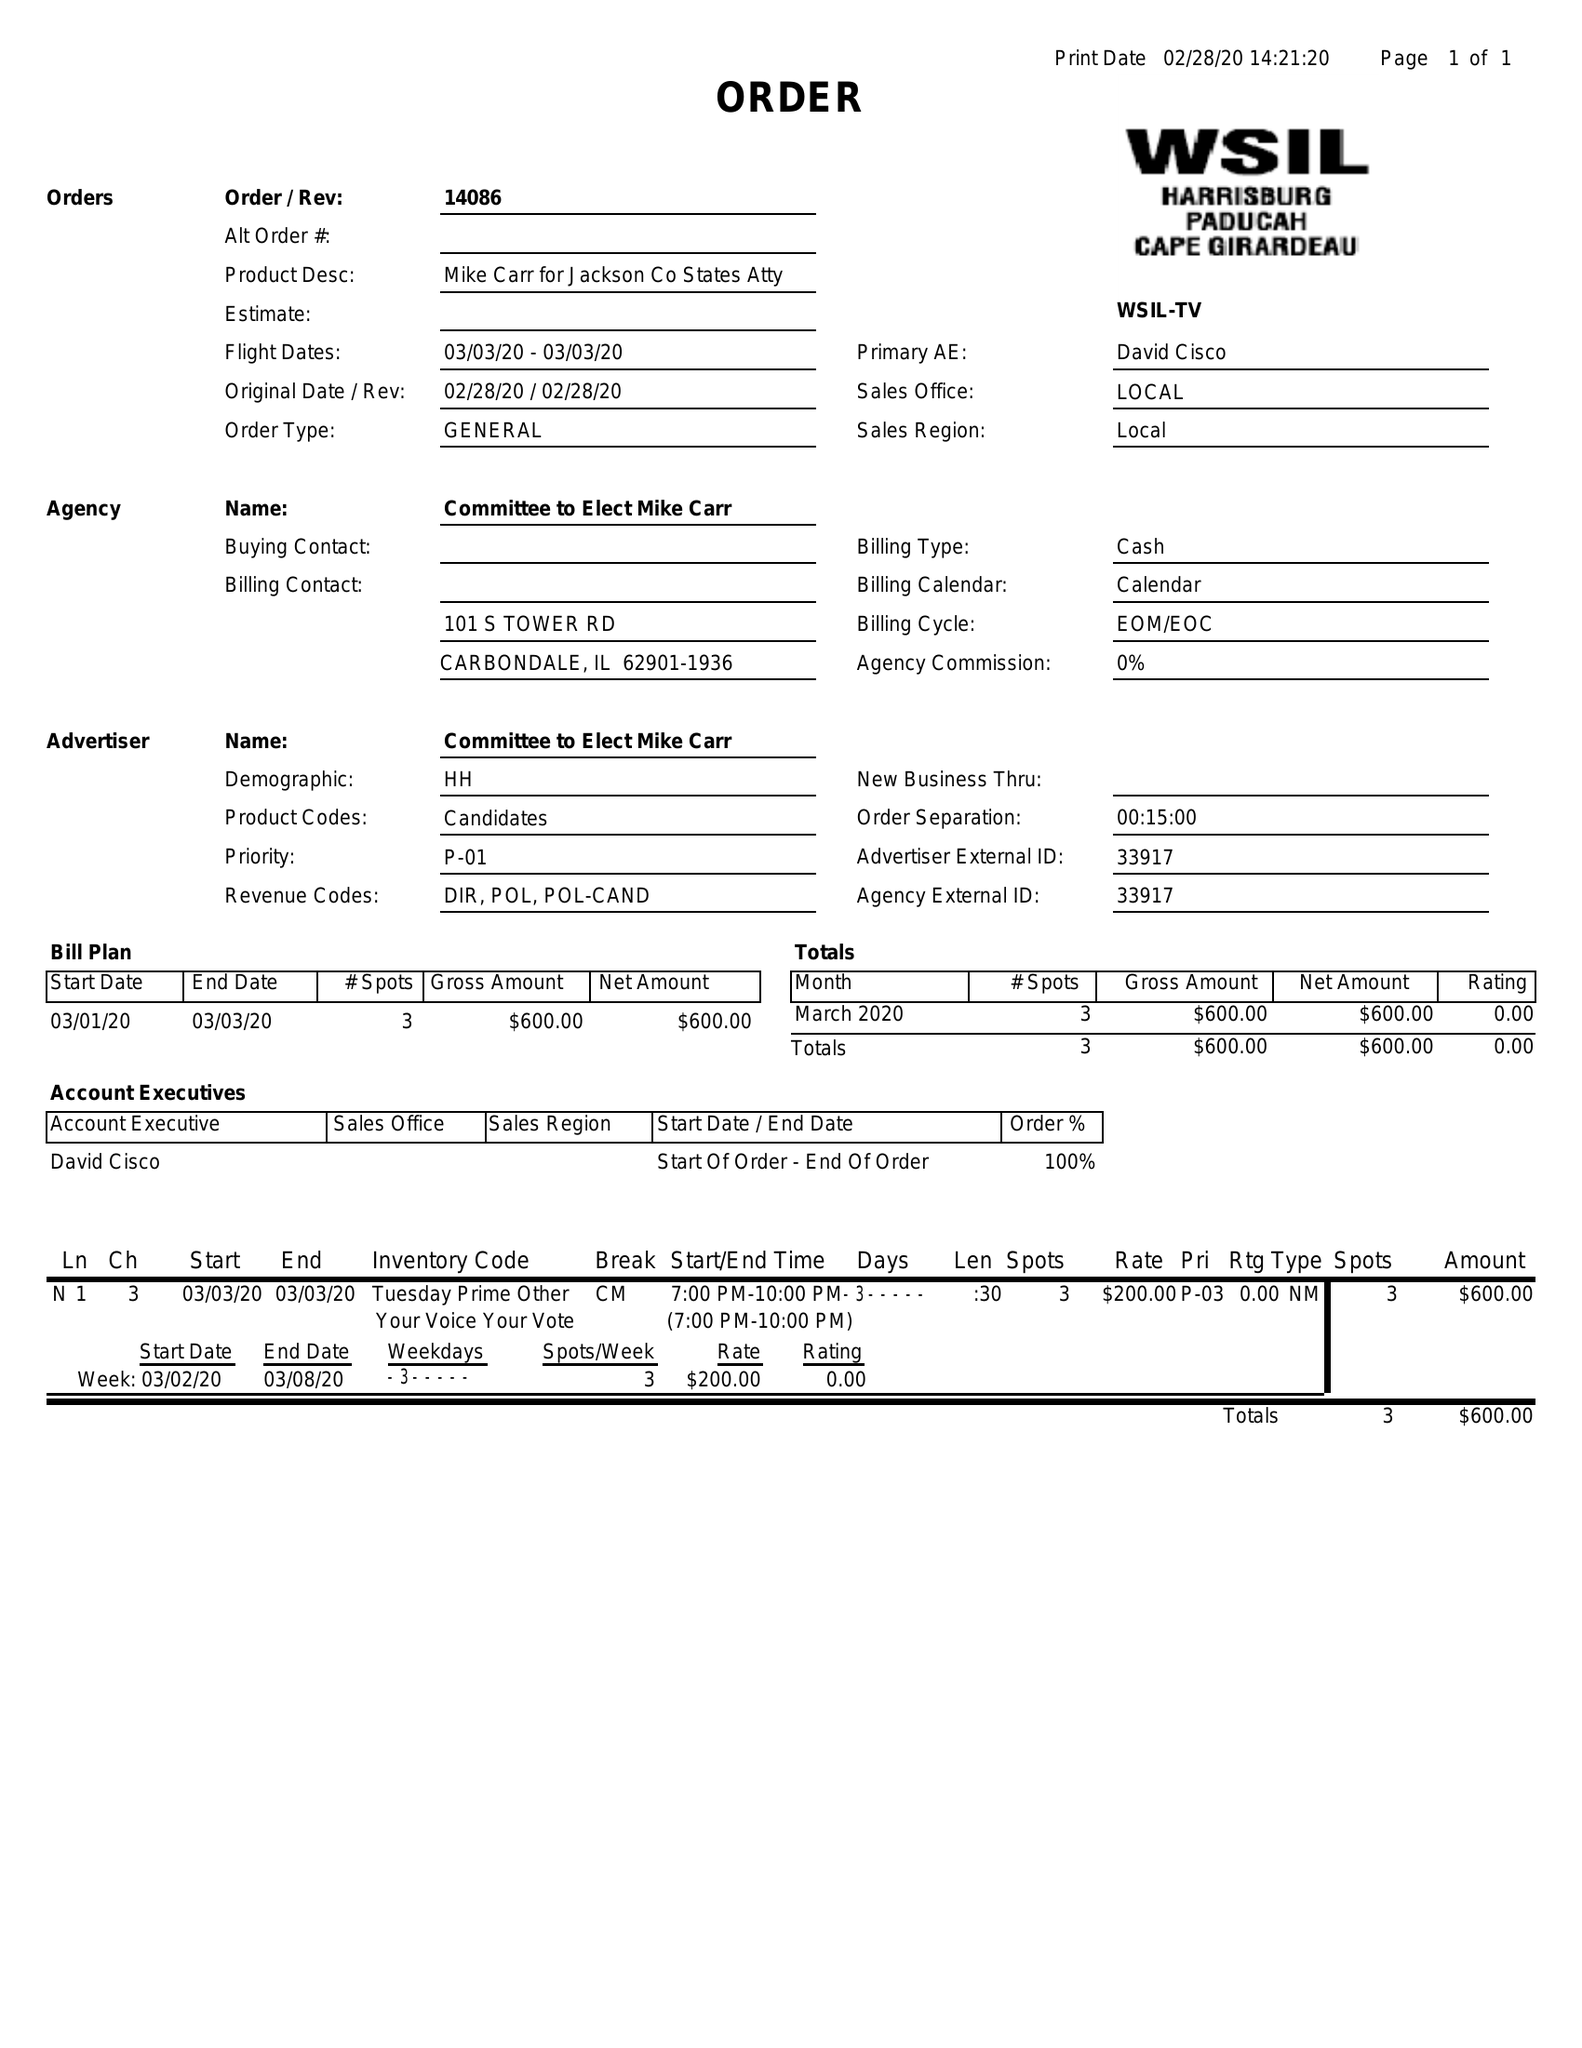What is the value for the contract_num?
Answer the question using a single word or phrase. 14086 